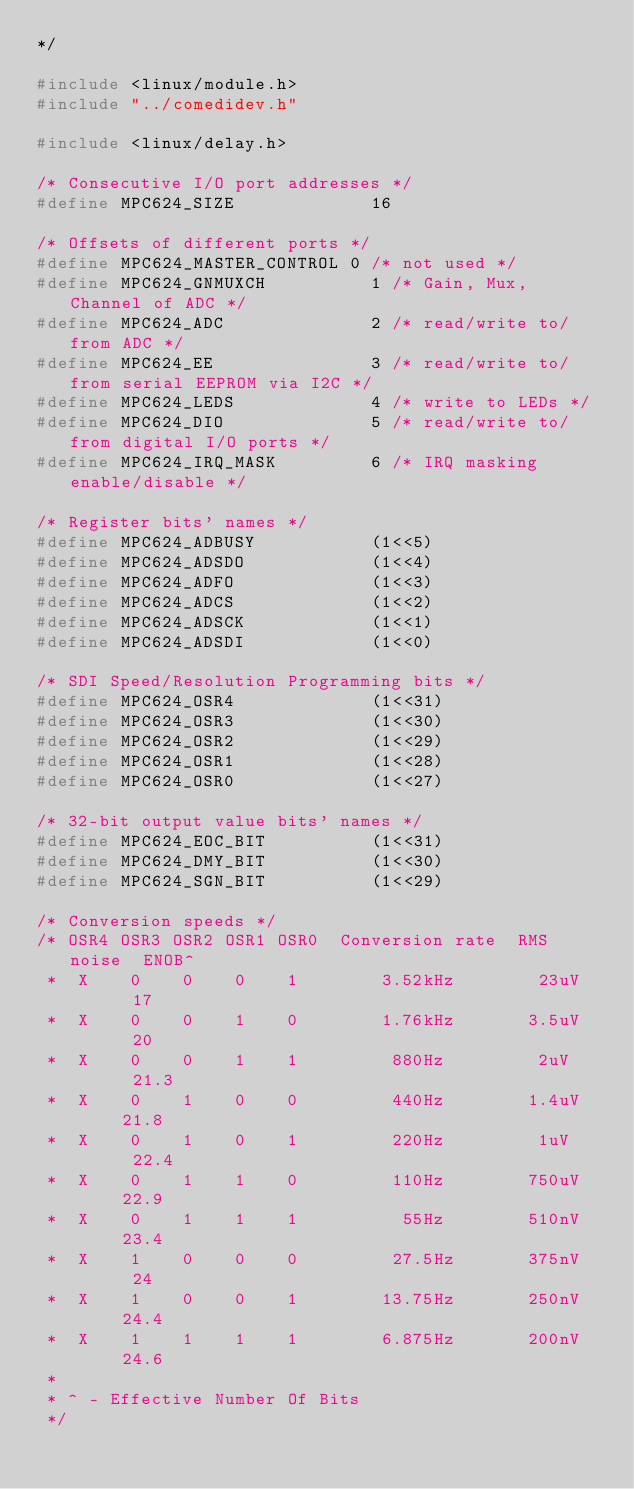Convert code to text. <code><loc_0><loc_0><loc_500><loc_500><_C_>*/

#include <linux/module.h>
#include "../comedidev.h"

#include <linux/delay.h>

/* Consecutive I/O port addresses */
#define MPC624_SIZE             16

/* Offsets of different ports */
#define MPC624_MASTER_CONTROL	0 /* not used */
#define MPC624_GNMUXCH          1 /* Gain, Mux, Channel of ADC */
#define MPC624_ADC              2 /* read/write to/from ADC */
#define MPC624_EE               3 /* read/write to/from serial EEPROM via I2C */
#define MPC624_LEDS             4 /* write to LEDs */
#define MPC624_DIO              5 /* read/write to/from digital I/O ports */
#define MPC624_IRQ_MASK         6 /* IRQ masking enable/disable */

/* Register bits' names */
#define MPC624_ADBUSY           (1<<5)
#define MPC624_ADSDO            (1<<4)
#define MPC624_ADFO             (1<<3)
#define MPC624_ADCS             (1<<2)
#define MPC624_ADSCK            (1<<1)
#define MPC624_ADSDI            (1<<0)

/* SDI Speed/Resolution Programming bits */
#define MPC624_OSR4             (1<<31)
#define MPC624_OSR3             (1<<30)
#define MPC624_OSR2             (1<<29)
#define MPC624_OSR1             (1<<28)
#define MPC624_OSR0             (1<<27)

/* 32-bit output value bits' names */
#define MPC624_EOC_BIT          (1<<31)
#define MPC624_DMY_BIT          (1<<30)
#define MPC624_SGN_BIT          (1<<29)

/* Conversion speeds */
/* OSR4 OSR3 OSR2 OSR1 OSR0  Conversion rate  RMS noise  ENOB^
 *  X    0    0    0    1        3.52kHz        23uV      17
 *  X    0    0    1    0        1.76kHz       3.5uV      20
 *  X    0    0    1    1         880Hz         2uV      21.3
 *  X    0    1    0    0         440Hz        1.4uV     21.8
 *  X    0    1    0    1         220Hz         1uV      22.4
 *  X    0    1    1    0         110Hz        750uV     22.9
 *  X    0    1    1    1          55Hz        510nV     23.4
 *  X    1    0    0    0         27.5Hz       375nV      24
 *  X    1    0    0    1        13.75Hz       250nV     24.4
 *  X    1    1    1    1        6.875Hz       200nV     24.6
 *
 * ^ - Effective Number Of Bits
 */
</code> 